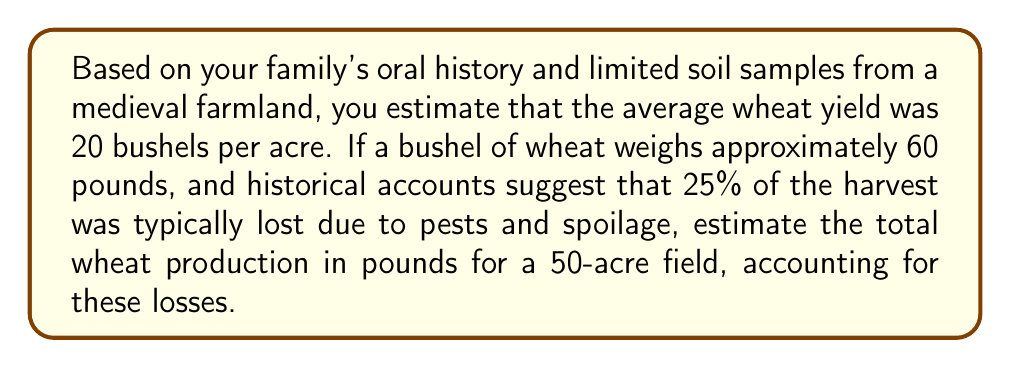Help me with this question. Let's approach this problem step-by-step:

1. Calculate the total yield without losses:
   $$ \text{Yield per acre} = 20 \text{ bushels} $$
   $$ \text{Total acres} = 50 $$
   $$ \text{Total bushels} = 20 \times 50 = 1000 \text{ bushels} $$

2. Convert bushels to pounds:
   $$ \text{Weight per bushel} = 60 \text{ pounds} $$
   $$ \text{Total weight} = 1000 \text{ bushels} \times 60 \text{ pounds/bushel} = 60,000 \text{ pounds} $$

3. Account for losses:
   $$ \text{Loss percentage} = 25\% = 0.25 $$
   $$ \text{Remaining percentage} = 1 - 0.25 = 0.75 \text{ or } 75\% $$

4. Calculate the final production after losses:
   $$ \text{Final production} = 60,000 \text{ pounds} \times 0.75 = 45,000 \text{ pounds} $$

Therefore, the total wheat production for the 50-acre field, accounting for losses, is 45,000 pounds.
Answer: 45,000 pounds 